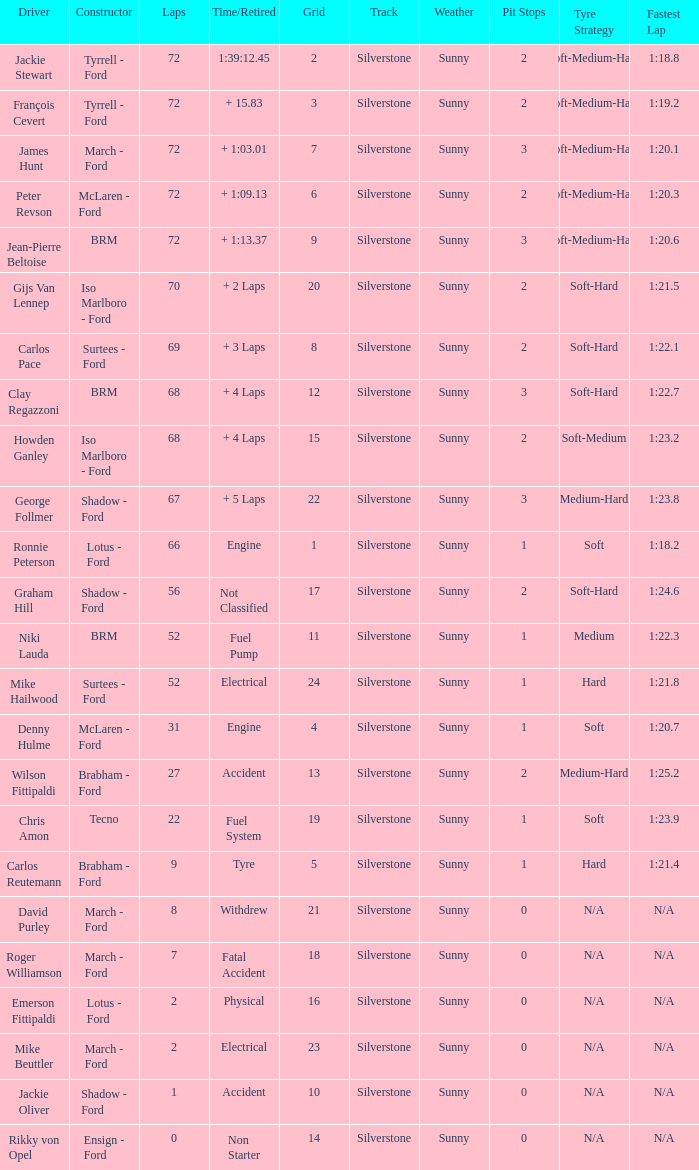What is the top lap that had a tyre time? 9.0. 